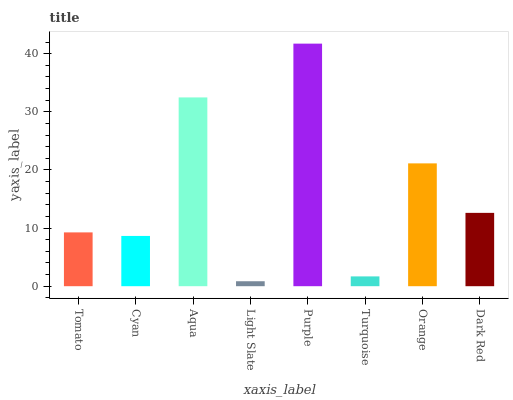Is Light Slate the minimum?
Answer yes or no. Yes. Is Purple the maximum?
Answer yes or no. Yes. Is Cyan the minimum?
Answer yes or no. No. Is Cyan the maximum?
Answer yes or no. No. Is Tomato greater than Cyan?
Answer yes or no. Yes. Is Cyan less than Tomato?
Answer yes or no. Yes. Is Cyan greater than Tomato?
Answer yes or no. No. Is Tomato less than Cyan?
Answer yes or no. No. Is Dark Red the high median?
Answer yes or no. Yes. Is Tomato the low median?
Answer yes or no. Yes. Is Light Slate the high median?
Answer yes or no. No. Is Dark Red the low median?
Answer yes or no. No. 